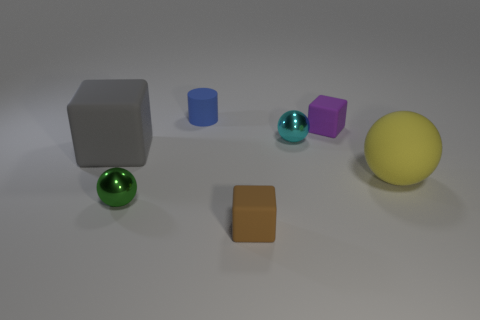Subtract all large balls. How many balls are left? 2 Add 3 small brown cubes. How many objects exist? 10 Subtract all brown cubes. How many cubes are left? 2 Subtract 3 balls. How many balls are left? 0 Subtract all cubes. How many objects are left? 4 Subtract 0 red balls. How many objects are left? 7 Subtract all yellow spheres. Subtract all gray cylinders. How many spheres are left? 2 Subtract all green blocks. How many red balls are left? 0 Subtract all blue cylinders. Subtract all large yellow things. How many objects are left? 5 Add 4 brown blocks. How many brown blocks are left? 5 